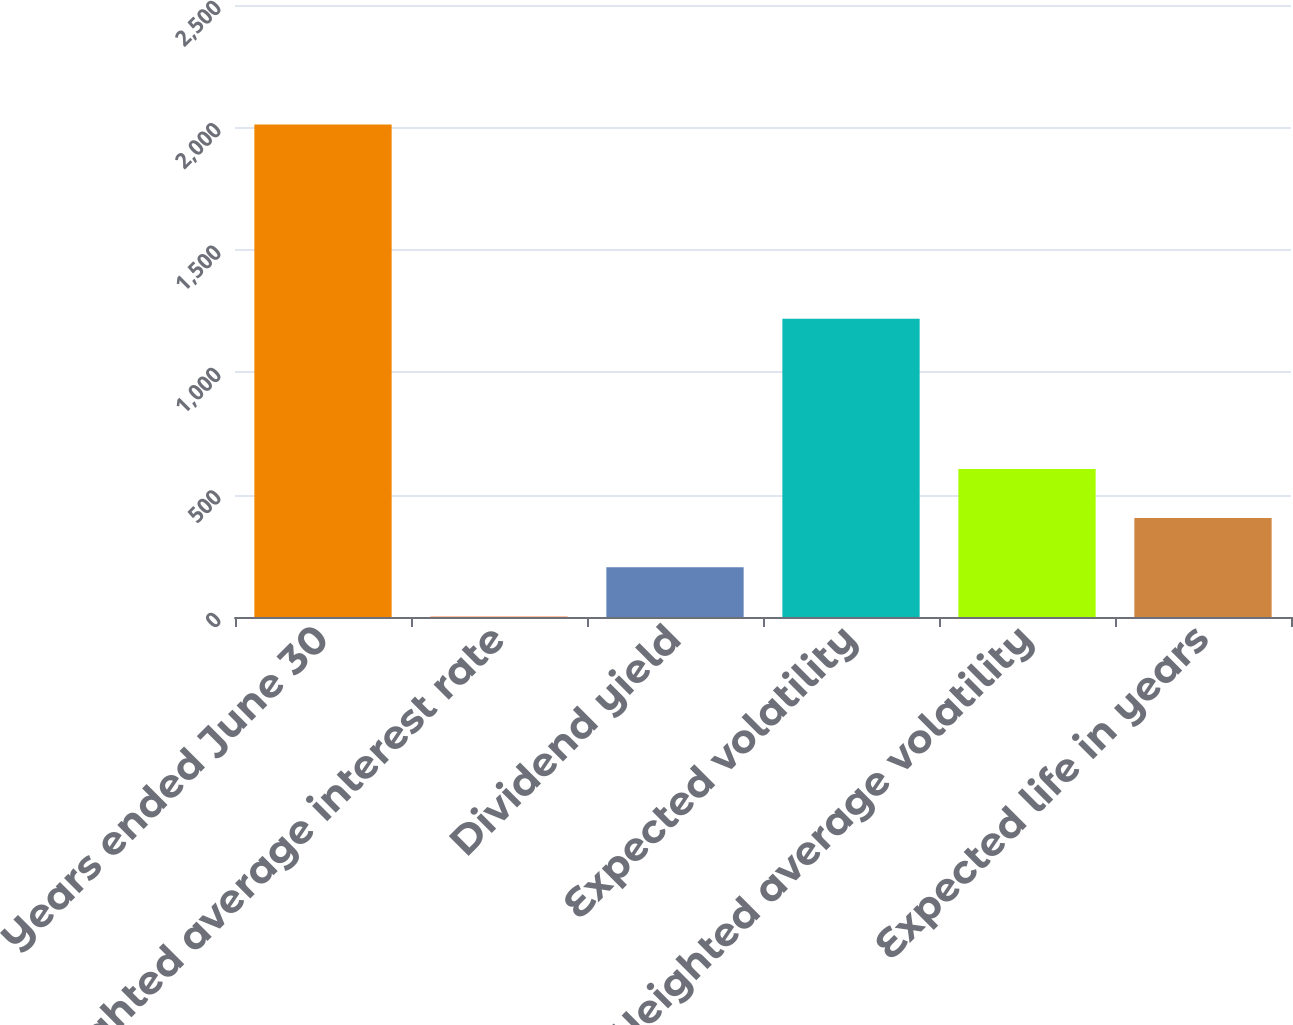Convert chart. <chart><loc_0><loc_0><loc_500><loc_500><bar_chart><fcel>Years ended June 30<fcel>Weighted average interest rate<fcel>Dividend yield<fcel>Expected volatility<fcel>Weighted average volatility<fcel>Expected life in years<nl><fcel>2012<fcel>1.9<fcel>202.91<fcel>1218<fcel>604.93<fcel>403.92<nl></chart> 